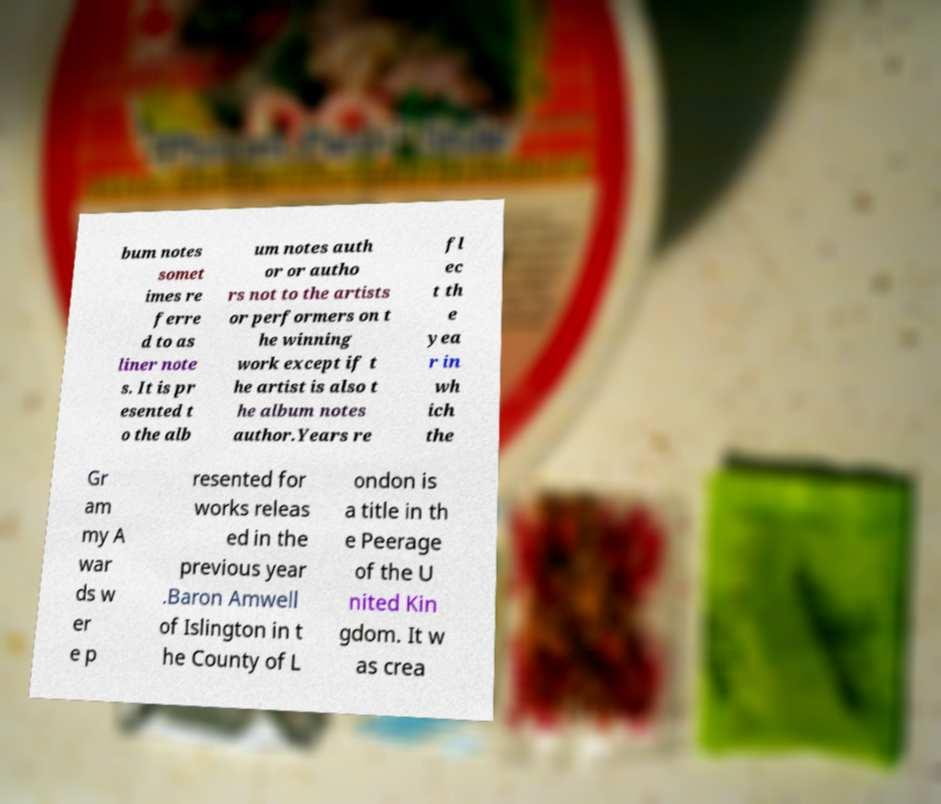I need the written content from this picture converted into text. Can you do that? bum notes somet imes re ferre d to as liner note s. It is pr esented t o the alb um notes auth or or autho rs not to the artists or performers on t he winning work except if t he artist is also t he album notes author.Years re fl ec t th e yea r in wh ich the Gr am my A war ds w er e p resented for works releas ed in the previous year .Baron Amwell of Islington in t he County of L ondon is a title in th e Peerage of the U nited Kin gdom. It w as crea 